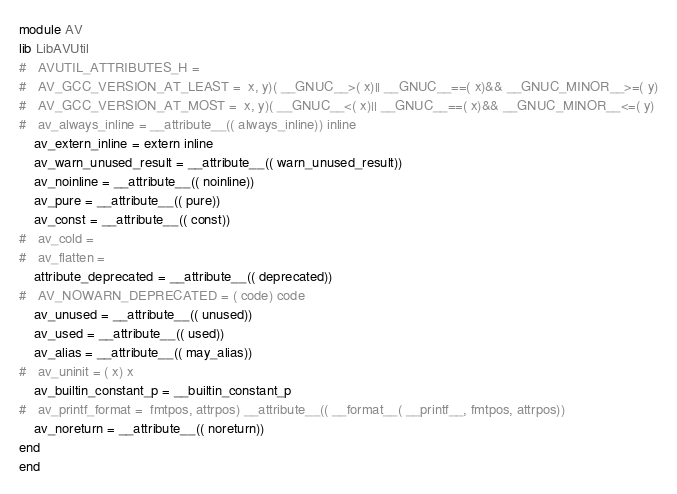Convert code to text. <code><loc_0><loc_0><loc_500><loc_500><_Crystal_>module AV
lib LibAVUtil
#   AVUTIL_ATTRIBUTES_H = 
#   AV_GCC_VERSION_AT_LEAST =  x, y)( __GNUC__>( x)|| __GNUC__==( x)&& __GNUC_MINOR__>=( y)
#   AV_GCC_VERSION_AT_MOST =  x, y)( __GNUC__<( x)|| __GNUC__==( x)&& __GNUC_MINOR__<=( y)
#   av_always_inline = __attribute__(( always_inline)) inline
    av_extern_inline = extern inline
    av_warn_unused_result = __attribute__(( warn_unused_result))
    av_noinline = __attribute__(( noinline))
    av_pure = __attribute__(( pure))
    av_const = __attribute__(( const))
#   av_cold = 
#   av_flatten = 
    attribute_deprecated = __attribute__(( deprecated))
#   AV_NOWARN_DEPRECATED = ( code) code
    av_unused = __attribute__(( unused))
    av_used = __attribute__(( used))
    av_alias = __attribute__(( may_alias))
#   av_uninit = ( x) x
    av_builtin_constant_p = __builtin_constant_p
#   av_printf_format =  fmtpos, attrpos) __attribute__(( __format__( __printf__, fmtpos, attrpos))
    av_noreturn = __attribute__(( noreturn))
end
end
</code> 